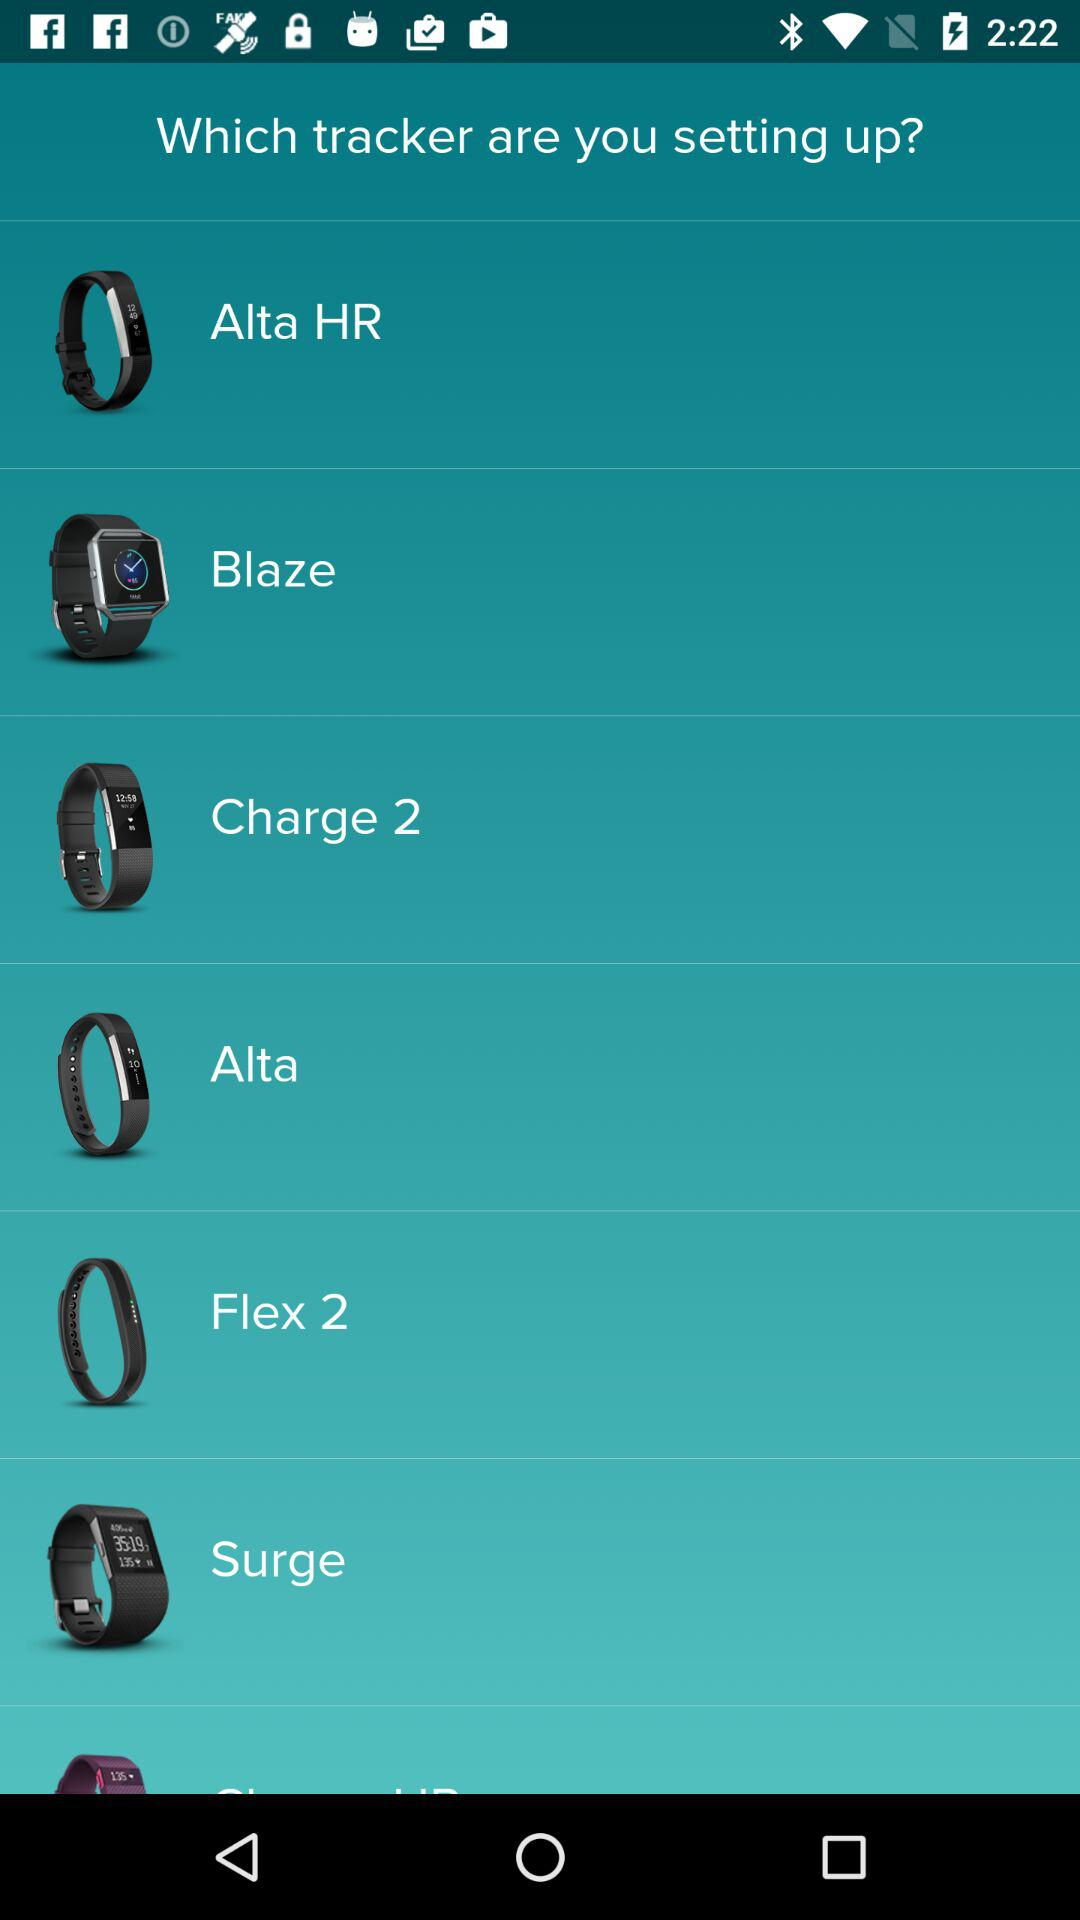What are the different trackers? The different trackers are "Alta HR", "Blaze", "Charge 2", "Alta", "Flex 2" and "Surge". 